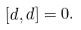<formula> <loc_0><loc_0><loc_500><loc_500>[ d , d ] = 0 .</formula> 